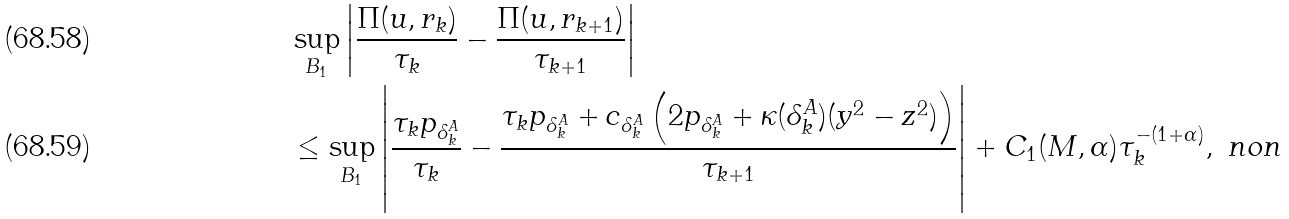<formula> <loc_0><loc_0><loc_500><loc_500>& \sup _ { B _ { 1 } } \left | \frac { \Pi ( u , r _ { k } ) } { \tau _ { k } } - \frac { \Pi ( u , r _ { k + 1 } ) } { \tau _ { k + 1 } } \right | \\ & \leq \sup _ { B _ { 1 } } \left | \frac { \tau _ { k } p _ { \delta ^ { A } _ { k } } } { \tau _ { k } } - \frac { \tau _ { k } p _ { \delta ^ { A } _ { k } } + c _ { \delta ^ { A } _ { k } } \left ( 2 p _ { \delta ^ { A } _ { k } } + \kappa ( \delta ^ { A } _ { k } ) ( y ^ { 2 } - z ^ { 2 } ) \right ) } { \tau _ { k + 1 } } \right | + C _ { 1 } ( M , \alpha ) \tau _ { k } ^ { - ( 1 + \alpha ) } , \ n o n</formula> 